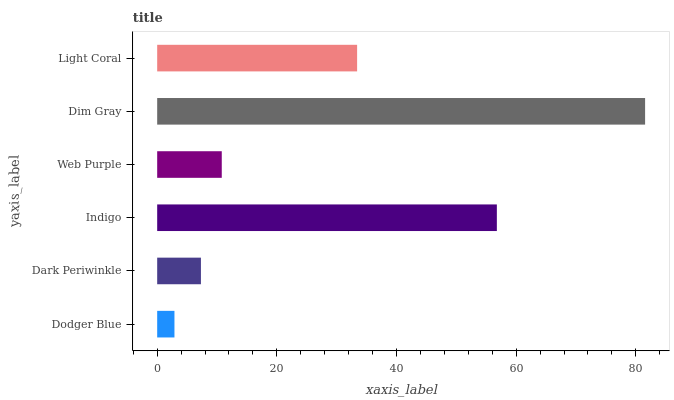Is Dodger Blue the minimum?
Answer yes or no. Yes. Is Dim Gray the maximum?
Answer yes or no. Yes. Is Dark Periwinkle the minimum?
Answer yes or no. No. Is Dark Periwinkle the maximum?
Answer yes or no. No. Is Dark Periwinkle greater than Dodger Blue?
Answer yes or no. Yes. Is Dodger Blue less than Dark Periwinkle?
Answer yes or no. Yes. Is Dodger Blue greater than Dark Periwinkle?
Answer yes or no. No. Is Dark Periwinkle less than Dodger Blue?
Answer yes or no. No. Is Light Coral the high median?
Answer yes or no. Yes. Is Web Purple the low median?
Answer yes or no. Yes. Is Dark Periwinkle the high median?
Answer yes or no. No. Is Dodger Blue the low median?
Answer yes or no. No. 